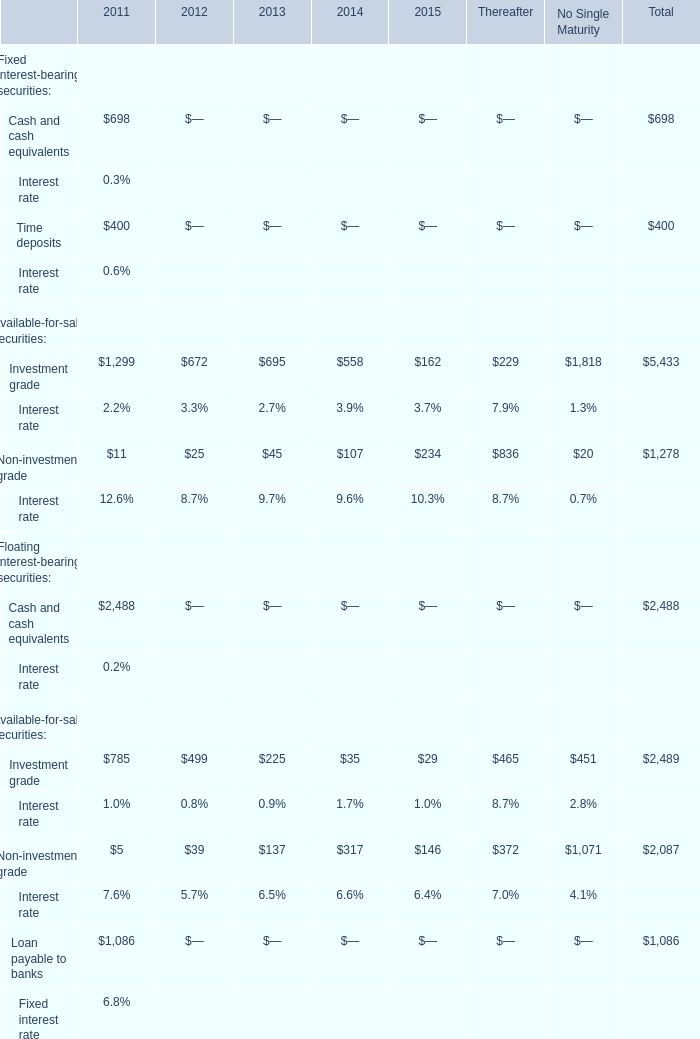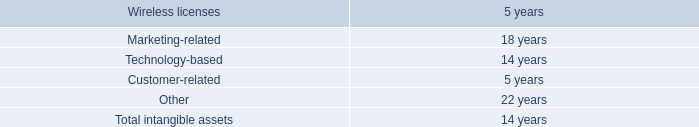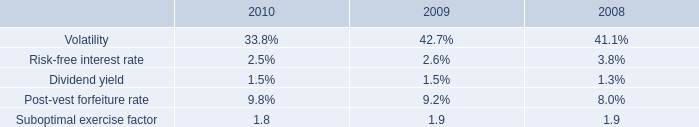What is the sum of Cash and cash equivalents in 2011 and Suboptimal exercise factor in 2010? 
Computations: (698 + 1.8)
Answer: 699.8. 